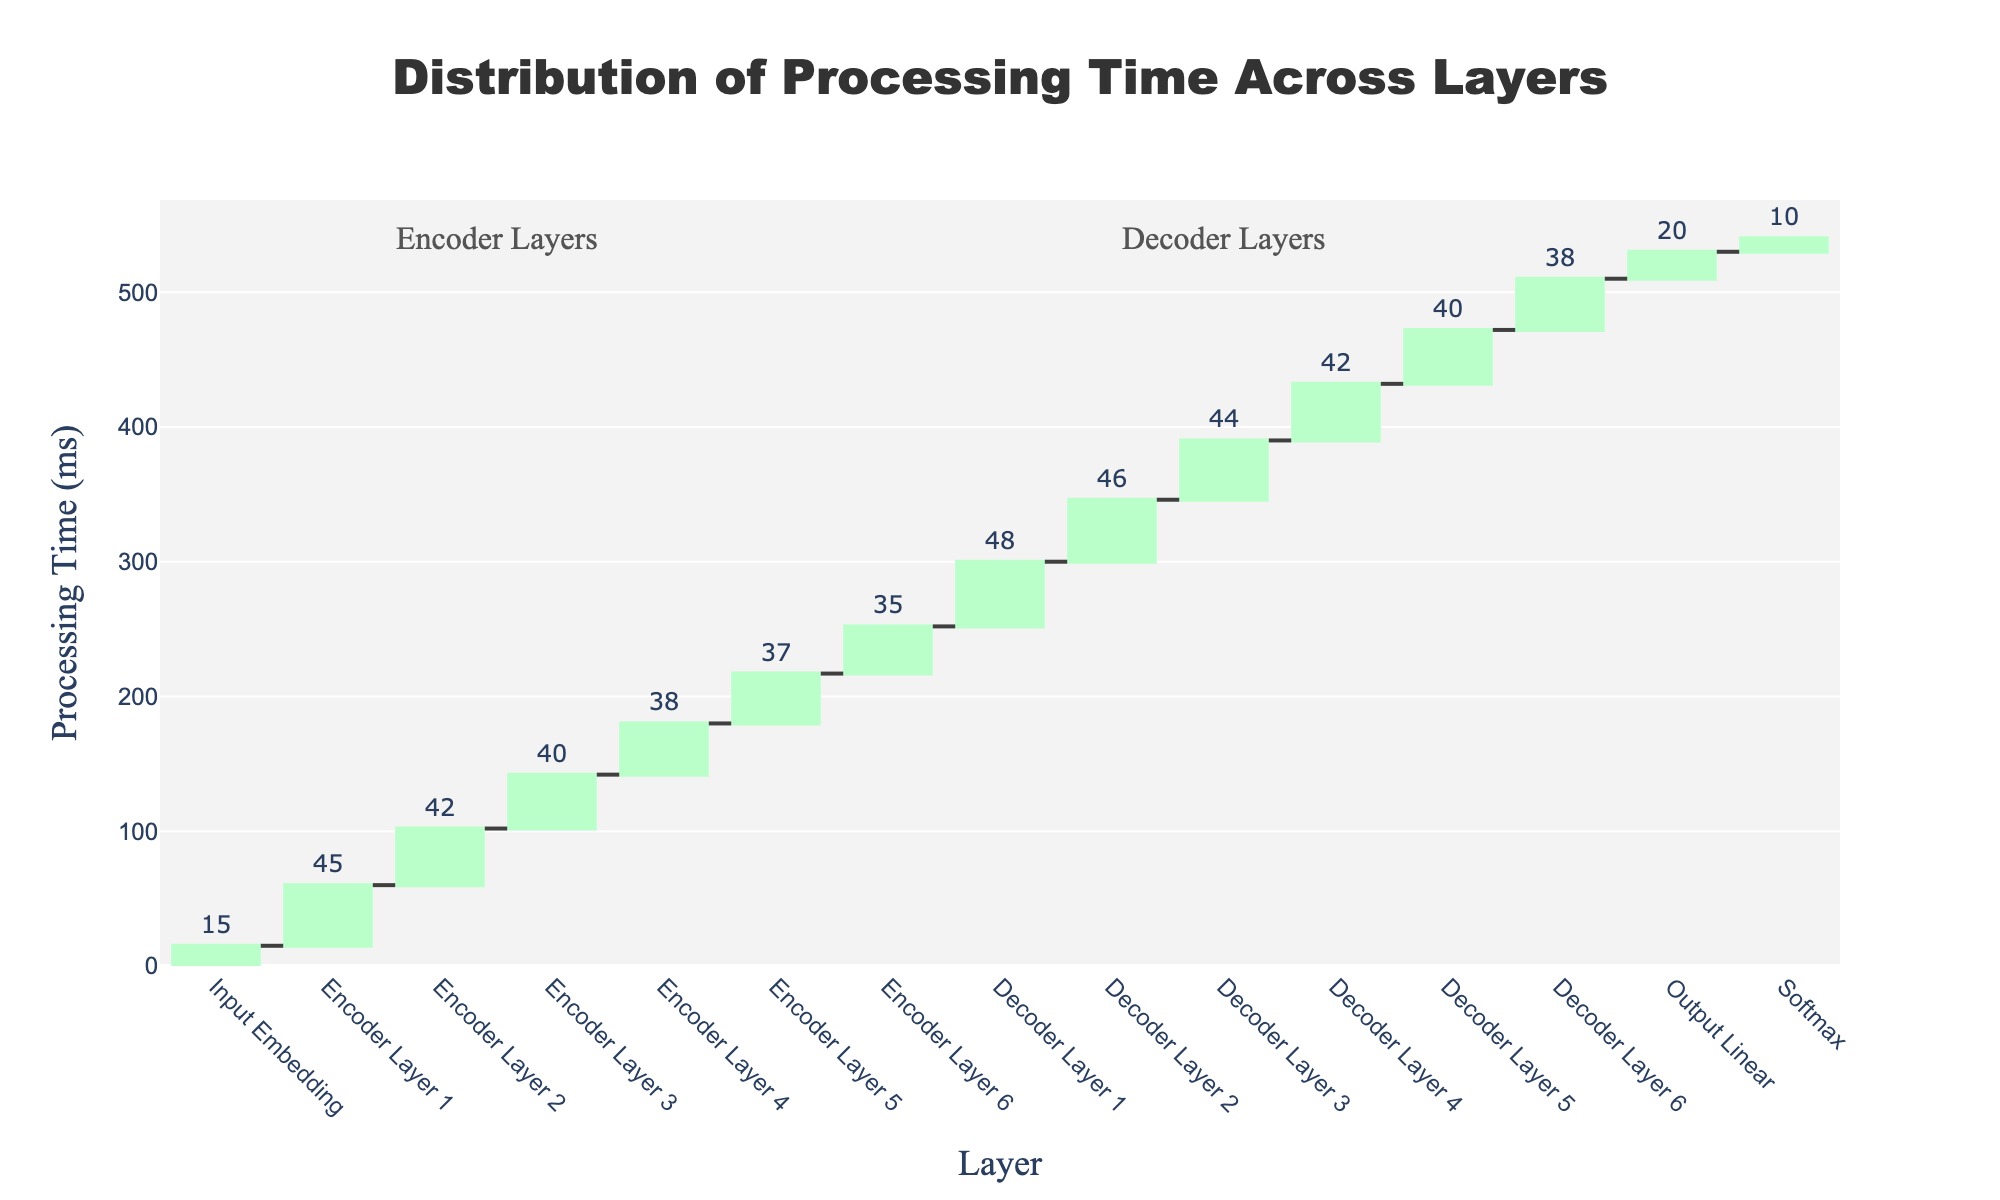What is the title of the chart? The title is generally located at the top of the chart and often provides a brief summary of what the chart is about. In this case, you should read the title written in bold and centered text at the top.
Answer: Distribution of Processing Time Across Layers How much processing time does the Input Embedding layer take? The processing time for the Input Embedding layer can be directly read from the chart where the Input Embedding label is located, usually depicted as a bar.
Answer: 15 ms Which layer has the highest processing time and how much is it? To find the highest processing time, locate the tallest bar or the bar with the largest value. In this chart, the Decoder Layer 1 has the highest processing time.
Answer: Decoder Layer 1, 48 ms What is the total combined processing time of Encoder Layers? Sum up the processing times of all Encoder Layers to get the total combined processing time. The times for Encoder Layers 1 to 6 are 45, 42, 40, 38, 37, and 35 ms, respectively.
Answer: 237 ms How does the processing time of the highest decoder layer compare with the sum of the highest and lowest encoder layers? First, find the highest decoder layer time (48 ms for Decoder Layer 1), then sum the highest (45 ms for Encoder Layer 1) and lowest (35 ms for Encoder Layer 6) encoder layer times; finally, compare the two values.
Answer: 48 ms vs. 80 ms What is the average processing time of all layers involved? To find the average processing time, add up the processing times of all layers and divide by the number of layers. The sum is (15 + 45 + 42 + 40 + 38 + 37 + 35 + 48 + 46 + 44 + 42 + 40 + 38 + 20 + 10) ms and there are 15 layers total.
Answer: 34.33 ms Between which layers does the largest drop in processing time occur? Compare the difference in processing times between consecutive layers to identify the largest drop. The largest drop occurs between Encoder Layer 1 (45 ms) and Encoder Layer 2 (42 ms), which is 3 ms.
Answer: Between Encoder Layer 1 and Encoder Layer 2 Which layers indicate the starting point of the Encoder and Decoder sections, based on annotations? Check the annotations on the chart that indicate the sections for Encoder and Decoder layers. The Encoder starts with Encoder Layer 1, and the Decoder starts with Decoder Layer 1.
Answer: Encoder Layer 1, Decoder Layer 1 What is the total processing time from Input Embedding to Softmax layers? Add up the processing times of all layers from Input Embedding to Softmax inclusive, which include Input Embedding, all Encoder and Decoder layers, Output Linear, and Softmax layers.
Answer: 480 ms 